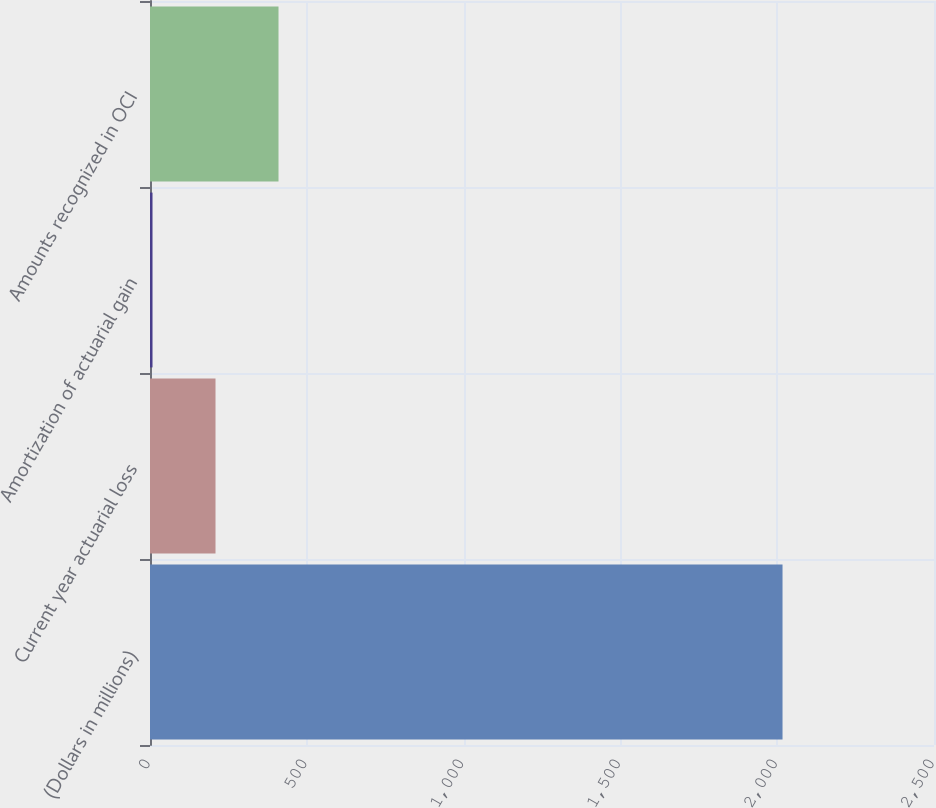<chart> <loc_0><loc_0><loc_500><loc_500><bar_chart><fcel>(Dollars in millions)<fcel>Current year actuarial loss<fcel>Amortization of actuarial gain<fcel>Amounts recognized in OCI<nl><fcel>2017<fcel>208.9<fcel>8<fcel>409.8<nl></chart> 